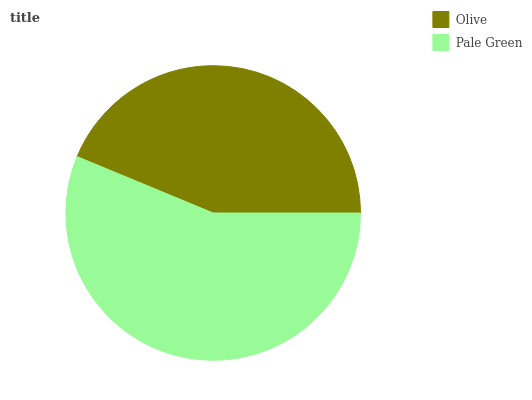Is Olive the minimum?
Answer yes or no. Yes. Is Pale Green the maximum?
Answer yes or no. Yes. Is Pale Green the minimum?
Answer yes or no. No. Is Pale Green greater than Olive?
Answer yes or no. Yes. Is Olive less than Pale Green?
Answer yes or no. Yes. Is Olive greater than Pale Green?
Answer yes or no. No. Is Pale Green less than Olive?
Answer yes or no. No. Is Pale Green the high median?
Answer yes or no. Yes. Is Olive the low median?
Answer yes or no. Yes. Is Olive the high median?
Answer yes or no. No. Is Pale Green the low median?
Answer yes or no. No. 